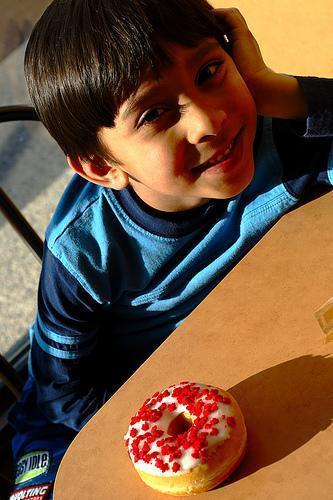How many items are on the table?
Give a very brief answer. 1. 